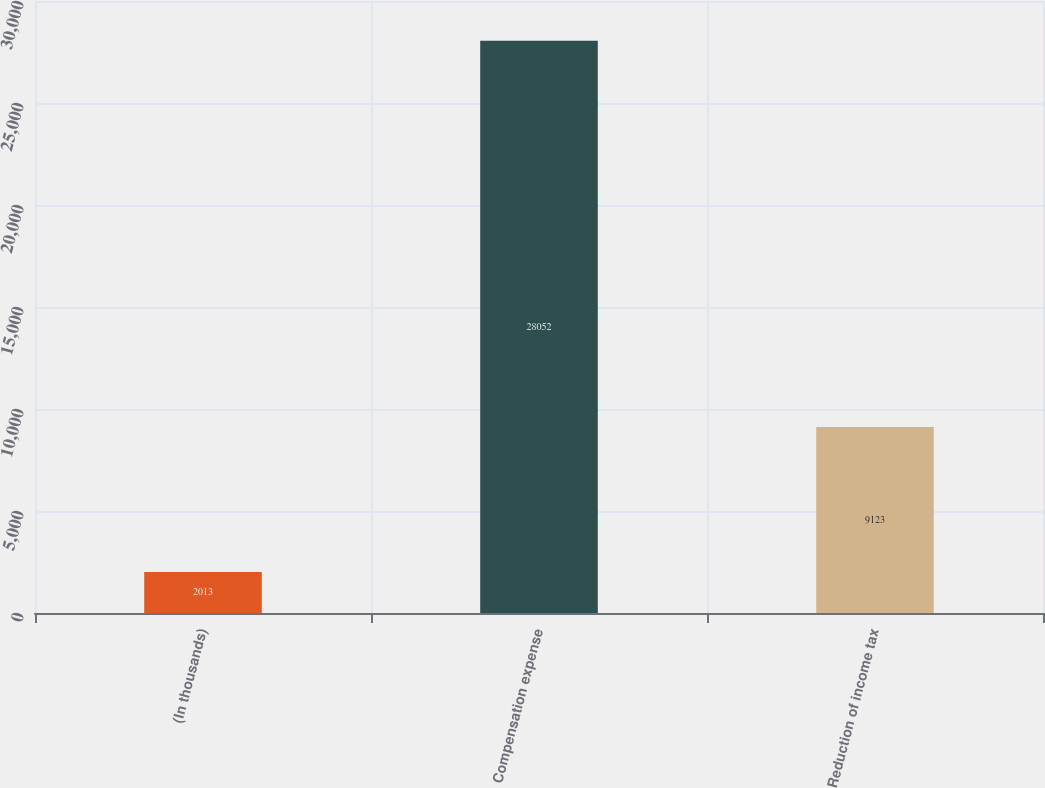<chart> <loc_0><loc_0><loc_500><loc_500><bar_chart><fcel>(In thousands)<fcel>Compensation expense<fcel>Reduction of income tax<nl><fcel>2013<fcel>28052<fcel>9123<nl></chart> 